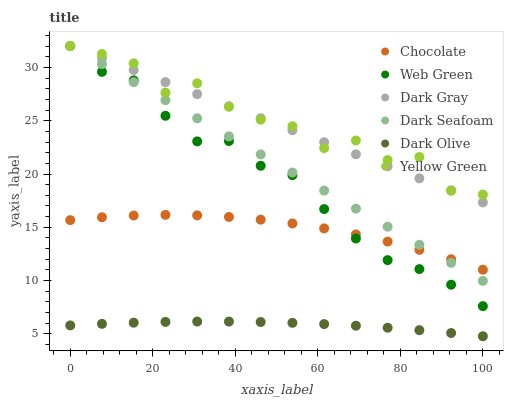Does Dark Olive have the minimum area under the curve?
Answer yes or no. Yes. Does Yellow Green have the maximum area under the curve?
Answer yes or no. Yes. Does Web Green have the minimum area under the curve?
Answer yes or no. No. Does Web Green have the maximum area under the curve?
Answer yes or no. No. Is Dark Gray the smoothest?
Answer yes or no. Yes. Is Yellow Green the roughest?
Answer yes or no. Yes. Is Dark Olive the smoothest?
Answer yes or no. No. Is Dark Olive the roughest?
Answer yes or no. No. Does Dark Olive have the lowest value?
Answer yes or no. Yes. Does Web Green have the lowest value?
Answer yes or no. No. Does Dark Seafoam have the highest value?
Answer yes or no. Yes. Does Web Green have the highest value?
Answer yes or no. No. Is Chocolate less than Dark Gray?
Answer yes or no. Yes. Is Dark Gray greater than Dark Olive?
Answer yes or no. Yes. Does Dark Seafoam intersect Dark Gray?
Answer yes or no. Yes. Is Dark Seafoam less than Dark Gray?
Answer yes or no. No. Is Dark Seafoam greater than Dark Gray?
Answer yes or no. No. Does Chocolate intersect Dark Gray?
Answer yes or no. No. 